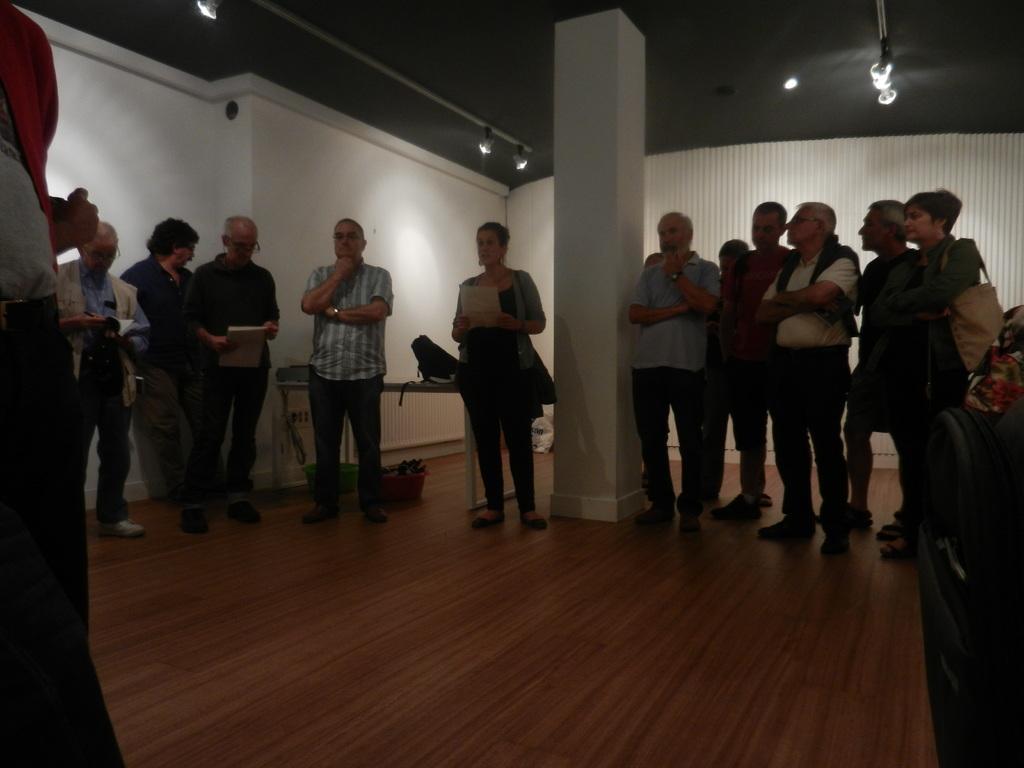Describe this image in one or two sentences. This image is taken indoors. At the bottom of the image there is a floor. At the top of the image there is a ceiling with a few lights. In the background there is a wall. In the middle of the image there is a pillar and a few people are standing on the floor and there is a table with a backpack on it. 